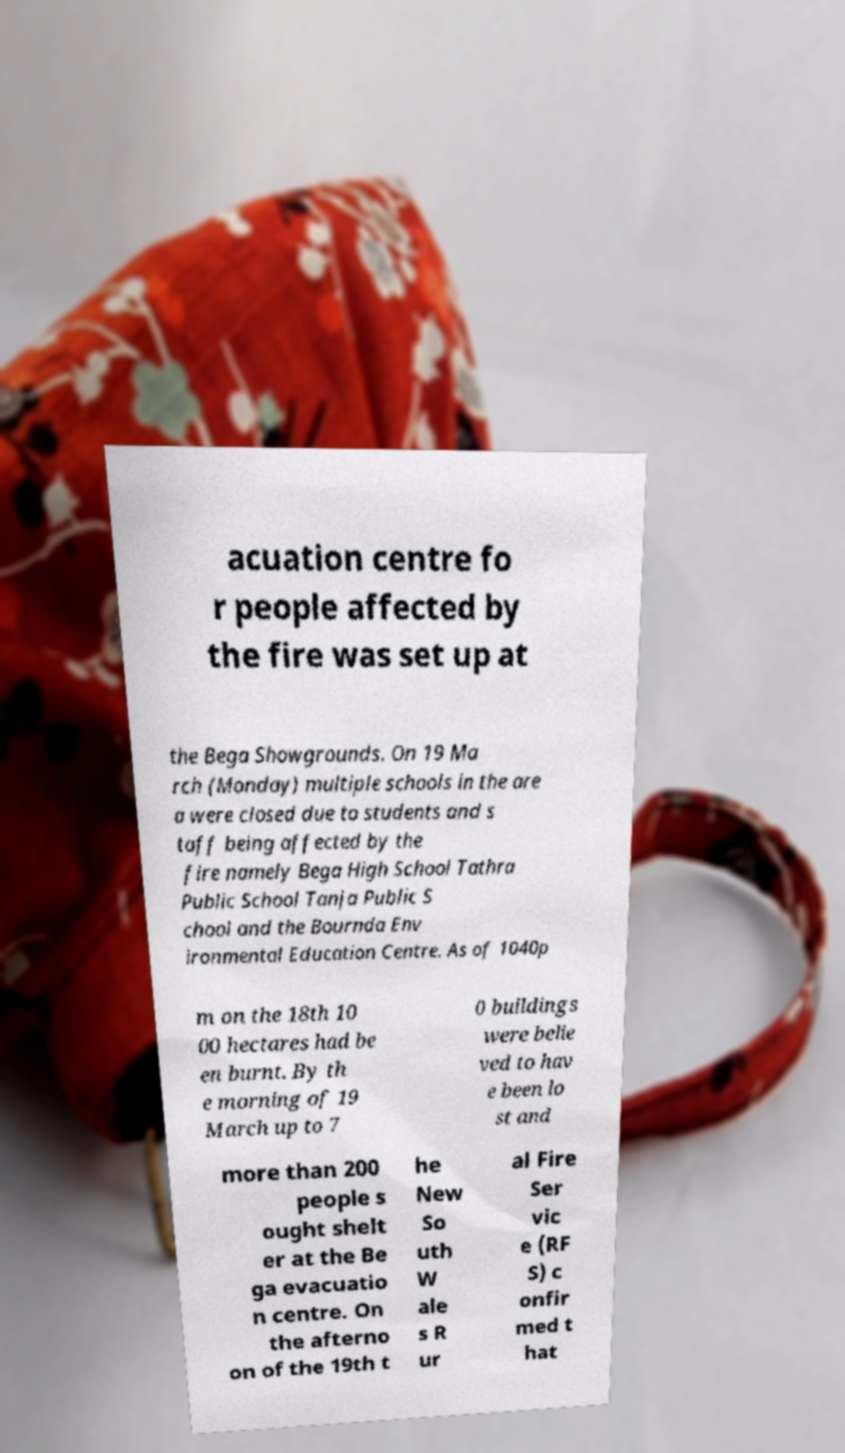Could you extract and type out the text from this image? acuation centre fo r people affected by the fire was set up at the Bega Showgrounds. On 19 Ma rch (Monday) multiple schools in the are a were closed due to students and s taff being affected by the fire namely Bega High School Tathra Public School Tanja Public S chool and the Bournda Env ironmental Education Centre. As of 1040p m on the 18th 10 00 hectares had be en burnt. By th e morning of 19 March up to 7 0 buildings were belie ved to hav e been lo st and more than 200 people s ought shelt er at the Be ga evacuatio n centre. On the afterno on of the 19th t he New So uth W ale s R ur al Fire Ser vic e (RF S) c onfir med t hat 